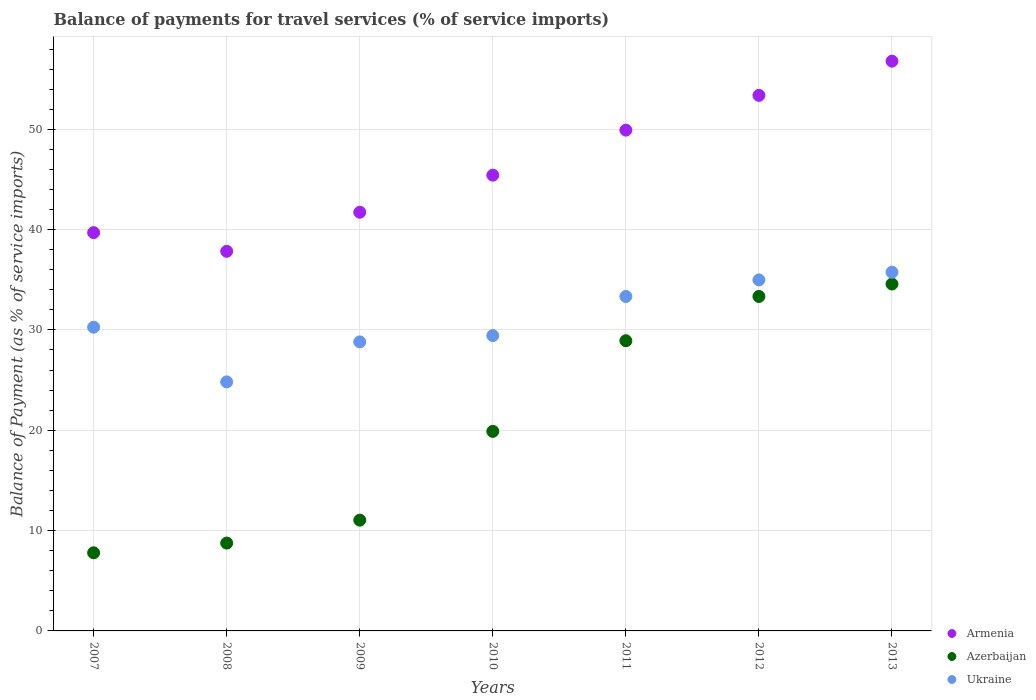How many different coloured dotlines are there?
Keep it short and to the point. 3. What is the balance of payments for travel services in Ukraine in 2011?
Offer a terse response. 33.33. Across all years, what is the maximum balance of payments for travel services in Armenia?
Your answer should be compact. 56.79. Across all years, what is the minimum balance of payments for travel services in Armenia?
Your answer should be compact. 37.84. In which year was the balance of payments for travel services in Ukraine maximum?
Offer a terse response. 2013. In which year was the balance of payments for travel services in Ukraine minimum?
Provide a succinct answer. 2008. What is the total balance of payments for travel services in Ukraine in the graph?
Provide a short and direct response. 217.41. What is the difference between the balance of payments for travel services in Armenia in 2007 and that in 2011?
Your answer should be very brief. -10.22. What is the difference between the balance of payments for travel services in Azerbaijan in 2011 and the balance of payments for travel services in Armenia in 2010?
Provide a short and direct response. -16.5. What is the average balance of payments for travel services in Armenia per year?
Ensure brevity in your answer.  46.4. In the year 2013, what is the difference between the balance of payments for travel services in Armenia and balance of payments for travel services in Ukraine?
Keep it short and to the point. 21.04. In how many years, is the balance of payments for travel services in Ukraine greater than 42 %?
Make the answer very short. 0. What is the ratio of the balance of payments for travel services in Ukraine in 2007 to that in 2013?
Offer a terse response. 0.85. What is the difference between the highest and the second highest balance of payments for travel services in Azerbaijan?
Your answer should be very brief. 1.24. What is the difference between the highest and the lowest balance of payments for travel services in Azerbaijan?
Give a very brief answer. 26.79. In how many years, is the balance of payments for travel services in Ukraine greater than the average balance of payments for travel services in Ukraine taken over all years?
Give a very brief answer. 3. Is the balance of payments for travel services in Armenia strictly less than the balance of payments for travel services in Ukraine over the years?
Provide a succinct answer. No. How many dotlines are there?
Your response must be concise. 3. How many years are there in the graph?
Your answer should be compact. 7. What is the difference between two consecutive major ticks on the Y-axis?
Make the answer very short. 10. Are the values on the major ticks of Y-axis written in scientific E-notation?
Keep it short and to the point. No. Where does the legend appear in the graph?
Your answer should be compact. Bottom right. How are the legend labels stacked?
Provide a succinct answer. Vertical. What is the title of the graph?
Your answer should be very brief. Balance of payments for travel services (% of service imports). What is the label or title of the Y-axis?
Your response must be concise. Balance of Payment (as % of service imports). What is the Balance of Payment (as % of service imports) of Armenia in 2007?
Your answer should be compact. 39.7. What is the Balance of Payment (as % of service imports) in Azerbaijan in 2007?
Your answer should be compact. 7.79. What is the Balance of Payment (as % of service imports) in Ukraine in 2007?
Provide a succinct answer. 30.27. What is the Balance of Payment (as % of service imports) in Armenia in 2008?
Your answer should be very brief. 37.84. What is the Balance of Payment (as % of service imports) of Azerbaijan in 2008?
Your answer should be very brief. 8.75. What is the Balance of Payment (as % of service imports) of Ukraine in 2008?
Ensure brevity in your answer.  24.82. What is the Balance of Payment (as % of service imports) of Armenia in 2009?
Your answer should be very brief. 41.73. What is the Balance of Payment (as % of service imports) of Azerbaijan in 2009?
Your answer should be very brief. 11.04. What is the Balance of Payment (as % of service imports) in Ukraine in 2009?
Keep it short and to the point. 28.81. What is the Balance of Payment (as % of service imports) of Armenia in 2010?
Give a very brief answer. 45.43. What is the Balance of Payment (as % of service imports) of Azerbaijan in 2010?
Provide a succinct answer. 19.89. What is the Balance of Payment (as % of service imports) in Ukraine in 2010?
Offer a terse response. 29.44. What is the Balance of Payment (as % of service imports) in Armenia in 2011?
Offer a terse response. 49.91. What is the Balance of Payment (as % of service imports) of Azerbaijan in 2011?
Keep it short and to the point. 28.92. What is the Balance of Payment (as % of service imports) in Ukraine in 2011?
Offer a very short reply. 33.33. What is the Balance of Payment (as % of service imports) in Armenia in 2012?
Offer a very short reply. 53.38. What is the Balance of Payment (as % of service imports) in Azerbaijan in 2012?
Provide a succinct answer. 33.34. What is the Balance of Payment (as % of service imports) of Ukraine in 2012?
Ensure brevity in your answer.  34.99. What is the Balance of Payment (as % of service imports) in Armenia in 2013?
Keep it short and to the point. 56.79. What is the Balance of Payment (as % of service imports) in Azerbaijan in 2013?
Give a very brief answer. 34.57. What is the Balance of Payment (as % of service imports) in Ukraine in 2013?
Offer a terse response. 35.75. Across all years, what is the maximum Balance of Payment (as % of service imports) in Armenia?
Your response must be concise. 56.79. Across all years, what is the maximum Balance of Payment (as % of service imports) in Azerbaijan?
Keep it short and to the point. 34.57. Across all years, what is the maximum Balance of Payment (as % of service imports) in Ukraine?
Offer a terse response. 35.75. Across all years, what is the minimum Balance of Payment (as % of service imports) of Armenia?
Your answer should be very brief. 37.84. Across all years, what is the minimum Balance of Payment (as % of service imports) of Azerbaijan?
Offer a very short reply. 7.79. Across all years, what is the minimum Balance of Payment (as % of service imports) of Ukraine?
Ensure brevity in your answer.  24.82. What is the total Balance of Payment (as % of service imports) in Armenia in the graph?
Make the answer very short. 324.77. What is the total Balance of Payment (as % of service imports) in Azerbaijan in the graph?
Provide a short and direct response. 144.31. What is the total Balance of Payment (as % of service imports) of Ukraine in the graph?
Keep it short and to the point. 217.41. What is the difference between the Balance of Payment (as % of service imports) of Armenia in 2007 and that in 2008?
Provide a short and direct response. 1.86. What is the difference between the Balance of Payment (as % of service imports) in Azerbaijan in 2007 and that in 2008?
Give a very brief answer. -0.97. What is the difference between the Balance of Payment (as % of service imports) of Ukraine in 2007 and that in 2008?
Provide a short and direct response. 5.45. What is the difference between the Balance of Payment (as % of service imports) in Armenia in 2007 and that in 2009?
Your response must be concise. -2.03. What is the difference between the Balance of Payment (as % of service imports) in Azerbaijan in 2007 and that in 2009?
Provide a short and direct response. -3.26. What is the difference between the Balance of Payment (as % of service imports) of Ukraine in 2007 and that in 2009?
Offer a terse response. 1.47. What is the difference between the Balance of Payment (as % of service imports) in Armenia in 2007 and that in 2010?
Make the answer very short. -5.73. What is the difference between the Balance of Payment (as % of service imports) in Azerbaijan in 2007 and that in 2010?
Keep it short and to the point. -12.1. What is the difference between the Balance of Payment (as % of service imports) in Ukraine in 2007 and that in 2010?
Provide a succinct answer. 0.83. What is the difference between the Balance of Payment (as % of service imports) in Armenia in 2007 and that in 2011?
Your response must be concise. -10.22. What is the difference between the Balance of Payment (as % of service imports) in Azerbaijan in 2007 and that in 2011?
Make the answer very short. -21.14. What is the difference between the Balance of Payment (as % of service imports) in Ukraine in 2007 and that in 2011?
Give a very brief answer. -3.06. What is the difference between the Balance of Payment (as % of service imports) in Armenia in 2007 and that in 2012?
Give a very brief answer. -13.68. What is the difference between the Balance of Payment (as % of service imports) of Azerbaijan in 2007 and that in 2012?
Offer a terse response. -25.55. What is the difference between the Balance of Payment (as % of service imports) in Ukraine in 2007 and that in 2012?
Keep it short and to the point. -4.71. What is the difference between the Balance of Payment (as % of service imports) in Armenia in 2007 and that in 2013?
Provide a succinct answer. -17.09. What is the difference between the Balance of Payment (as % of service imports) in Azerbaijan in 2007 and that in 2013?
Provide a succinct answer. -26.79. What is the difference between the Balance of Payment (as % of service imports) in Ukraine in 2007 and that in 2013?
Give a very brief answer. -5.48. What is the difference between the Balance of Payment (as % of service imports) of Armenia in 2008 and that in 2009?
Your answer should be compact. -3.89. What is the difference between the Balance of Payment (as % of service imports) in Azerbaijan in 2008 and that in 2009?
Your answer should be very brief. -2.29. What is the difference between the Balance of Payment (as % of service imports) of Ukraine in 2008 and that in 2009?
Your answer should be very brief. -3.99. What is the difference between the Balance of Payment (as % of service imports) of Armenia in 2008 and that in 2010?
Your answer should be compact. -7.59. What is the difference between the Balance of Payment (as % of service imports) in Azerbaijan in 2008 and that in 2010?
Offer a very short reply. -11.13. What is the difference between the Balance of Payment (as % of service imports) of Ukraine in 2008 and that in 2010?
Offer a terse response. -4.62. What is the difference between the Balance of Payment (as % of service imports) of Armenia in 2008 and that in 2011?
Provide a succinct answer. -12.08. What is the difference between the Balance of Payment (as % of service imports) in Azerbaijan in 2008 and that in 2011?
Your answer should be compact. -20.17. What is the difference between the Balance of Payment (as % of service imports) of Ukraine in 2008 and that in 2011?
Your answer should be compact. -8.51. What is the difference between the Balance of Payment (as % of service imports) in Armenia in 2008 and that in 2012?
Your answer should be very brief. -15.54. What is the difference between the Balance of Payment (as % of service imports) in Azerbaijan in 2008 and that in 2012?
Offer a terse response. -24.58. What is the difference between the Balance of Payment (as % of service imports) in Ukraine in 2008 and that in 2012?
Ensure brevity in your answer.  -10.16. What is the difference between the Balance of Payment (as % of service imports) in Armenia in 2008 and that in 2013?
Make the answer very short. -18.95. What is the difference between the Balance of Payment (as % of service imports) in Azerbaijan in 2008 and that in 2013?
Keep it short and to the point. -25.82. What is the difference between the Balance of Payment (as % of service imports) in Ukraine in 2008 and that in 2013?
Offer a very short reply. -10.93. What is the difference between the Balance of Payment (as % of service imports) of Armenia in 2009 and that in 2010?
Keep it short and to the point. -3.7. What is the difference between the Balance of Payment (as % of service imports) of Azerbaijan in 2009 and that in 2010?
Offer a terse response. -8.85. What is the difference between the Balance of Payment (as % of service imports) of Ukraine in 2009 and that in 2010?
Your answer should be compact. -0.63. What is the difference between the Balance of Payment (as % of service imports) in Armenia in 2009 and that in 2011?
Your response must be concise. -8.19. What is the difference between the Balance of Payment (as % of service imports) in Azerbaijan in 2009 and that in 2011?
Your response must be concise. -17.88. What is the difference between the Balance of Payment (as % of service imports) in Ukraine in 2009 and that in 2011?
Provide a succinct answer. -4.53. What is the difference between the Balance of Payment (as % of service imports) in Armenia in 2009 and that in 2012?
Provide a short and direct response. -11.65. What is the difference between the Balance of Payment (as % of service imports) of Azerbaijan in 2009 and that in 2012?
Your answer should be compact. -22.3. What is the difference between the Balance of Payment (as % of service imports) in Ukraine in 2009 and that in 2012?
Make the answer very short. -6.18. What is the difference between the Balance of Payment (as % of service imports) in Armenia in 2009 and that in 2013?
Provide a short and direct response. -15.06. What is the difference between the Balance of Payment (as % of service imports) of Azerbaijan in 2009 and that in 2013?
Your answer should be compact. -23.53. What is the difference between the Balance of Payment (as % of service imports) of Ukraine in 2009 and that in 2013?
Make the answer very short. -6.95. What is the difference between the Balance of Payment (as % of service imports) in Armenia in 2010 and that in 2011?
Offer a very short reply. -4.49. What is the difference between the Balance of Payment (as % of service imports) in Azerbaijan in 2010 and that in 2011?
Offer a very short reply. -9.04. What is the difference between the Balance of Payment (as % of service imports) of Ukraine in 2010 and that in 2011?
Provide a short and direct response. -3.9. What is the difference between the Balance of Payment (as % of service imports) in Armenia in 2010 and that in 2012?
Ensure brevity in your answer.  -7.95. What is the difference between the Balance of Payment (as % of service imports) of Azerbaijan in 2010 and that in 2012?
Offer a terse response. -13.45. What is the difference between the Balance of Payment (as % of service imports) in Ukraine in 2010 and that in 2012?
Provide a short and direct response. -5.55. What is the difference between the Balance of Payment (as % of service imports) of Armenia in 2010 and that in 2013?
Keep it short and to the point. -11.36. What is the difference between the Balance of Payment (as % of service imports) in Azerbaijan in 2010 and that in 2013?
Ensure brevity in your answer.  -14.69. What is the difference between the Balance of Payment (as % of service imports) in Ukraine in 2010 and that in 2013?
Your answer should be compact. -6.32. What is the difference between the Balance of Payment (as % of service imports) in Armenia in 2011 and that in 2012?
Give a very brief answer. -3.46. What is the difference between the Balance of Payment (as % of service imports) in Azerbaijan in 2011 and that in 2012?
Ensure brevity in your answer.  -4.41. What is the difference between the Balance of Payment (as % of service imports) of Ukraine in 2011 and that in 2012?
Ensure brevity in your answer.  -1.65. What is the difference between the Balance of Payment (as % of service imports) in Armenia in 2011 and that in 2013?
Your response must be concise. -6.87. What is the difference between the Balance of Payment (as % of service imports) in Azerbaijan in 2011 and that in 2013?
Offer a terse response. -5.65. What is the difference between the Balance of Payment (as % of service imports) of Ukraine in 2011 and that in 2013?
Offer a very short reply. -2.42. What is the difference between the Balance of Payment (as % of service imports) of Armenia in 2012 and that in 2013?
Ensure brevity in your answer.  -3.41. What is the difference between the Balance of Payment (as % of service imports) in Azerbaijan in 2012 and that in 2013?
Provide a succinct answer. -1.24. What is the difference between the Balance of Payment (as % of service imports) of Ukraine in 2012 and that in 2013?
Ensure brevity in your answer.  -0.77. What is the difference between the Balance of Payment (as % of service imports) of Armenia in 2007 and the Balance of Payment (as % of service imports) of Azerbaijan in 2008?
Your answer should be very brief. 30.94. What is the difference between the Balance of Payment (as % of service imports) in Armenia in 2007 and the Balance of Payment (as % of service imports) in Ukraine in 2008?
Keep it short and to the point. 14.88. What is the difference between the Balance of Payment (as % of service imports) of Azerbaijan in 2007 and the Balance of Payment (as % of service imports) of Ukraine in 2008?
Give a very brief answer. -17.04. What is the difference between the Balance of Payment (as % of service imports) in Armenia in 2007 and the Balance of Payment (as % of service imports) in Azerbaijan in 2009?
Offer a terse response. 28.66. What is the difference between the Balance of Payment (as % of service imports) in Armenia in 2007 and the Balance of Payment (as % of service imports) in Ukraine in 2009?
Your response must be concise. 10.89. What is the difference between the Balance of Payment (as % of service imports) of Azerbaijan in 2007 and the Balance of Payment (as % of service imports) of Ukraine in 2009?
Provide a succinct answer. -21.02. What is the difference between the Balance of Payment (as % of service imports) in Armenia in 2007 and the Balance of Payment (as % of service imports) in Azerbaijan in 2010?
Your answer should be compact. 19.81. What is the difference between the Balance of Payment (as % of service imports) in Armenia in 2007 and the Balance of Payment (as % of service imports) in Ukraine in 2010?
Provide a succinct answer. 10.26. What is the difference between the Balance of Payment (as % of service imports) of Azerbaijan in 2007 and the Balance of Payment (as % of service imports) of Ukraine in 2010?
Provide a succinct answer. -21.65. What is the difference between the Balance of Payment (as % of service imports) in Armenia in 2007 and the Balance of Payment (as % of service imports) in Azerbaijan in 2011?
Make the answer very short. 10.77. What is the difference between the Balance of Payment (as % of service imports) of Armenia in 2007 and the Balance of Payment (as % of service imports) of Ukraine in 2011?
Your response must be concise. 6.36. What is the difference between the Balance of Payment (as % of service imports) of Azerbaijan in 2007 and the Balance of Payment (as % of service imports) of Ukraine in 2011?
Your answer should be very brief. -25.55. What is the difference between the Balance of Payment (as % of service imports) in Armenia in 2007 and the Balance of Payment (as % of service imports) in Azerbaijan in 2012?
Make the answer very short. 6.36. What is the difference between the Balance of Payment (as % of service imports) of Armenia in 2007 and the Balance of Payment (as % of service imports) of Ukraine in 2012?
Your answer should be very brief. 4.71. What is the difference between the Balance of Payment (as % of service imports) in Azerbaijan in 2007 and the Balance of Payment (as % of service imports) in Ukraine in 2012?
Give a very brief answer. -27.2. What is the difference between the Balance of Payment (as % of service imports) in Armenia in 2007 and the Balance of Payment (as % of service imports) in Azerbaijan in 2013?
Offer a terse response. 5.12. What is the difference between the Balance of Payment (as % of service imports) in Armenia in 2007 and the Balance of Payment (as % of service imports) in Ukraine in 2013?
Your response must be concise. 3.95. What is the difference between the Balance of Payment (as % of service imports) of Azerbaijan in 2007 and the Balance of Payment (as % of service imports) of Ukraine in 2013?
Your answer should be very brief. -27.97. What is the difference between the Balance of Payment (as % of service imports) of Armenia in 2008 and the Balance of Payment (as % of service imports) of Azerbaijan in 2009?
Give a very brief answer. 26.8. What is the difference between the Balance of Payment (as % of service imports) in Armenia in 2008 and the Balance of Payment (as % of service imports) in Ukraine in 2009?
Keep it short and to the point. 9.03. What is the difference between the Balance of Payment (as % of service imports) of Azerbaijan in 2008 and the Balance of Payment (as % of service imports) of Ukraine in 2009?
Provide a succinct answer. -20.05. What is the difference between the Balance of Payment (as % of service imports) of Armenia in 2008 and the Balance of Payment (as % of service imports) of Azerbaijan in 2010?
Provide a succinct answer. 17.95. What is the difference between the Balance of Payment (as % of service imports) of Armenia in 2008 and the Balance of Payment (as % of service imports) of Ukraine in 2010?
Your answer should be very brief. 8.4. What is the difference between the Balance of Payment (as % of service imports) of Azerbaijan in 2008 and the Balance of Payment (as % of service imports) of Ukraine in 2010?
Make the answer very short. -20.68. What is the difference between the Balance of Payment (as % of service imports) in Armenia in 2008 and the Balance of Payment (as % of service imports) in Azerbaijan in 2011?
Offer a terse response. 8.91. What is the difference between the Balance of Payment (as % of service imports) of Armenia in 2008 and the Balance of Payment (as % of service imports) of Ukraine in 2011?
Your response must be concise. 4.5. What is the difference between the Balance of Payment (as % of service imports) of Azerbaijan in 2008 and the Balance of Payment (as % of service imports) of Ukraine in 2011?
Provide a short and direct response. -24.58. What is the difference between the Balance of Payment (as % of service imports) of Armenia in 2008 and the Balance of Payment (as % of service imports) of Azerbaijan in 2012?
Your response must be concise. 4.5. What is the difference between the Balance of Payment (as % of service imports) in Armenia in 2008 and the Balance of Payment (as % of service imports) in Ukraine in 2012?
Ensure brevity in your answer.  2.85. What is the difference between the Balance of Payment (as % of service imports) of Azerbaijan in 2008 and the Balance of Payment (as % of service imports) of Ukraine in 2012?
Keep it short and to the point. -26.23. What is the difference between the Balance of Payment (as % of service imports) in Armenia in 2008 and the Balance of Payment (as % of service imports) in Azerbaijan in 2013?
Your answer should be compact. 3.26. What is the difference between the Balance of Payment (as % of service imports) of Armenia in 2008 and the Balance of Payment (as % of service imports) of Ukraine in 2013?
Make the answer very short. 2.08. What is the difference between the Balance of Payment (as % of service imports) in Azerbaijan in 2008 and the Balance of Payment (as % of service imports) in Ukraine in 2013?
Provide a short and direct response. -27. What is the difference between the Balance of Payment (as % of service imports) in Armenia in 2009 and the Balance of Payment (as % of service imports) in Azerbaijan in 2010?
Provide a succinct answer. 21.84. What is the difference between the Balance of Payment (as % of service imports) of Armenia in 2009 and the Balance of Payment (as % of service imports) of Ukraine in 2010?
Make the answer very short. 12.29. What is the difference between the Balance of Payment (as % of service imports) in Azerbaijan in 2009 and the Balance of Payment (as % of service imports) in Ukraine in 2010?
Offer a very short reply. -18.4. What is the difference between the Balance of Payment (as % of service imports) in Armenia in 2009 and the Balance of Payment (as % of service imports) in Azerbaijan in 2011?
Your answer should be compact. 12.81. What is the difference between the Balance of Payment (as % of service imports) in Armenia in 2009 and the Balance of Payment (as % of service imports) in Ukraine in 2011?
Keep it short and to the point. 8.4. What is the difference between the Balance of Payment (as % of service imports) in Azerbaijan in 2009 and the Balance of Payment (as % of service imports) in Ukraine in 2011?
Offer a terse response. -22.29. What is the difference between the Balance of Payment (as % of service imports) in Armenia in 2009 and the Balance of Payment (as % of service imports) in Azerbaijan in 2012?
Give a very brief answer. 8.39. What is the difference between the Balance of Payment (as % of service imports) in Armenia in 2009 and the Balance of Payment (as % of service imports) in Ukraine in 2012?
Give a very brief answer. 6.74. What is the difference between the Balance of Payment (as % of service imports) in Azerbaijan in 2009 and the Balance of Payment (as % of service imports) in Ukraine in 2012?
Offer a terse response. -23.94. What is the difference between the Balance of Payment (as % of service imports) of Armenia in 2009 and the Balance of Payment (as % of service imports) of Azerbaijan in 2013?
Offer a very short reply. 7.15. What is the difference between the Balance of Payment (as % of service imports) in Armenia in 2009 and the Balance of Payment (as % of service imports) in Ukraine in 2013?
Offer a terse response. 5.98. What is the difference between the Balance of Payment (as % of service imports) of Azerbaijan in 2009 and the Balance of Payment (as % of service imports) of Ukraine in 2013?
Make the answer very short. -24.71. What is the difference between the Balance of Payment (as % of service imports) in Armenia in 2010 and the Balance of Payment (as % of service imports) in Azerbaijan in 2011?
Your answer should be compact. 16.5. What is the difference between the Balance of Payment (as % of service imports) of Armenia in 2010 and the Balance of Payment (as % of service imports) of Ukraine in 2011?
Your answer should be very brief. 12.09. What is the difference between the Balance of Payment (as % of service imports) in Azerbaijan in 2010 and the Balance of Payment (as % of service imports) in Ukraine in 2011?
Offer a very short reply. -13.44. What is the difference between the Balance of Payment (as % of service imports) in Armenia in 2010 and the Balance of Payment (as % of service imports) in Azerbaijan in 2012?
Make the answer very short. 12.09. What is the difference between the Balance of Payment (as % of service imports) in Armenia in 2010 and the Balance of Payment (as % of service imports) in Ukraine in 2012?
Your answer should be very brief. 10.44. What is the difference between the Balance of Payment (as % of service imports) in Azerbaijan in 2010 and the Balance of Payment (as % of service imports) in Ukraine in 2012?
Your answer should be very brief. -15.1. What is the difference between the Balance of Payment (as % of service imports) of Armenia in 2010 and the Balance of Payment (as % of service imports) of Azerbaijan in 2013?
Ensure brevity in your answer.  10.85. What is the difference between the Balance of Payment (as % of service imports) in Armenia in 2010 and the Balance of Payment (as % of service imports) in Ukraine in 2013?
Provide a succinct answer. 9.67. What is the difference between the Balance of Payment (as % of service imports) of Azerbaijan in 2010 and the Balance of Payment (as % of service imports) of Ukraine in 2013?
Provide a short and direct response. -15.86. What is the difference between the Balance of Payment (as % of service imports) in Armenia in 2011 and the Balance of Payment (as % of service imports) in Azerbaijan in 2012?
Ensure brevity in your answer.  16.58. What is the difference between the Balance of Payment (as % of service imports) of Armenia in 2011 and the Balance of Payment (as % of service imports) of Ukraine in 2012?
Provide a succinct answer. 14.93. What is the difference between the Balance of Payment (as % of service imports) in Azerbaijan in 2011 and the Balance of Payment (as % of service imports) in Ukraine in 2012?
Provide a short and direct response. -6.06. What is the difference between the Balance of Payment (as % of service imports) in Armenia in 2011 and the Balance of Payment (as % of service imports) in Azerbaijan in 2013?
Offer a terse response. 15.34. What is the difference between the Balance of Payment (as % of service imports) of Armenia in 2011 and the Balance of Payment (as % of service imports) of Ukraine in 2013?
Your answer should be compact. 14.16. What is the difference between the Balance of Payment (as % of service imports) in Azerbaijan in 2011 and the Balance of Payment (as % of service imports) in Ukraine in 2013?
Ensure brevity in your answer.  -6.83. What is the difference between the Balance of Payment (as % of service imports) in Armenia in 2012 and the Balance of Payment (as % of service imports) in Azerbaijan in 2013?
Offer a very short reply. 18.8. What is the difference between the Balance of Payment (as % of service imports) in Armenia in 2012 and the Balance of Payment (as % of service imports) in Ukraine in 2013?
Give a very brief answer. 17.63. What is the difference between the Balance of Payment (as % of service imports) in Azerbaijan in 2012 and the Balance of Payment (as % of service imports) in Ukraine in 2013?
Ensure brevity in your answer.  -2.42. What is the average Balance of Payment (as % of service imports) of Armenia per year?
Your answer should be compact. 46.4. What is the average Balance of Payment (as % of service imports) in Azerbaijan per year?
Provide a succinct answer. 20.62. What is the average Balance of Payment (as % of service imports) in Ukraine per year?
Offer a terse response. 31.06. In the year 2007, what is the difference between the Balance of Payment (as % of service imports) in Armenia and Balance of Payment (as % of service imports) in Azerbaijan?
Keep it short and to the point. 31.91. In the year 2007, what is the difference between the Balance of Payment (as % of service imports) of Armenia and Balance of Payment (as % of service imports) of Ukraine?
Your response must be concise. 9.43. In the year 2007, what is the difference between the Balance of Payment (as % of service imports) of Azerbaijan and Balance of Payment (as % of service imports) of Ukraine?
Your response must be concise. -22.49. In the year 2008, what is the difference between the Balance of Payment (as % of service imports) of Armenia and Balance of Payment (as % of service imports) of Azerbaijan?
Ensure brevity in your answer.  29.08. In the year 2008, what is the difference between the Balance of Payment (as % of service imports) in Armenia and Balance of Payment (as % of service imports) in Ukraine?
Your answer should be compact. 13.02. In the year 2008, what is the difference between the Balance of Payment (as % of service imports) in Azerbaijan and Balance of Payment (as % of service imports) in Ukraine?
Ensure brevity in your answer.  -16.07. In the year 2009, what is the difference between the Balance of Payment (as % of service imports) of Armenia and Balance of Payment (as % of service imports) of Azerbaijan?
Your answer should be very brief. 30.69. In the year 2009, what is the difference between the Balance of Payment (as % of service imports) of Armenia and Balance of Payment (as % of service imports) of Ukraine?
Your answer should be very brief. 12.92. In the year 2009, what is the difference between the Balance of Payment (as % of service imports) of Azerbaijan and Balance of Payment (as % of service imports) of Ukraine?
Your response must be concise. -17.77. In the year 2010, what is the difference between the Balance of Payment (as % of service imports) of Armenia and Balance of Payment (as % of service imports) of Azerbaijan?
Provide a succinct answer. 25.54. In the year 2010, what is the difference between the Balance of Payment (as % of service imports) of Armenia and Balance of Payment (as % of service imports) of Ukraine?
Your response must be concise. 15.99. In the year 2010, what is the difference between the Balance of Payment (as % of service imports) in Azerbaijan and Balance of Payment (as % of service imports) in Ukraine?
Your answer should be very brief. -9.55. In the year 2011, what is the difference between the Balance of Payment (as % of service imports) in Armenia and Balance of Payment (as % of service imports) in Azerbaijan?
Offer a very short reply. 20.99. In the year 2011, what is the difference between the Balance of Payment (as % of service imports) of Armenia and Balance of Payment (as % of service imports) of Ukraine?
Give a very brief answer. 16.58. In the year 2011, what is the difference between the Balance of Payment (as % of service imports) of Azerbaijan and Balance of Payment (as % of service imports) of Ukraine?
Offer a very short reply. -4.41. In the year 2012, what is the difference between the Balance of Payment (as % of service imports) in Armenia and Balance of Payment (as % of service imports) in Azerbaijan?
Make the answer very short. 20.04. In the year 2012, what is the difference between the Balance of Payment (as % of service imports) of Armenia and Balance of Payment (as % of service imports) of Ukraine?
Your answer should be compact. 18.39. In the year 2012, what is the difference between the Balance of Payment (as % of service imports) of Azerbaijan and Balance of Payment (as % of service imports) of Ukraine?
Your response must be concise. -1.65. In the year 2013, what is the difference between the Balance of Payment (as % of service imports) of Armenia and Balance of Payment (as % of service imports) of Azerbaijan?
Give a very brief answer. 22.21. In the year 2013, what is the difference between the Balance of Payment (as % of service imports) of Armenia and Balance of Payment (as % of service imports) of Ukraine?
Provide a succinct answer. 21.04. In the year 2013, what is the difference between the Balance of Payment (as % of service imports) in Azerbaijan and Balance of Payment (as % of service imports) in Ukraine?
Provide a succinct answer. -1.18. What is the ratio of the Balance of Payment (as % of service imports) of Armenia in 2007 to that in 2008?
Offer a terse response. 1.05. What is the ratio of the Balance of Payment (as % of service imports) of Azerbaijan in 2007 to that in 2008?
Your response must be concise. 0.89. What is the ratio of the Balance of Payment (as % of service imports) of Ukraine in 2007 to that in 2008?
Offer a very short reply. 1.22. What is the ratio of the Balance of Payment (as % of service imports) of Armenia in 2007 to that in 2009?
Make the answer very short. 0.95. What is the ratio of the Balance of Payment (as % of service imports) in Azerbaijan in 2007 to that in 2009?
Keep it short and to the point. 0.71. What is the ratio of the Balance of Payment (as % of service imports) in Ukraine in 2007 to that in 2009?
Offer a terse response. 1.05. What is the ratio of the Balance of Payment (as % of service imports) of Armenia in 2007 to that in 2010?
Your response must be concise. 0.87. What is the ratio of the Balance of Payment (as % of service imports) of Azerbaijan in 2007 to that in 2010?
Ensure brevity in your answer.  0.39. What is the ratio of the Balance of Payment (as % of service imports) in Ukraine in 2007 to that in 2010?
Your answer should be very brief. 1.03. What is the ratio of the Balance of Payment (as % of service imports) in Armenia in 2007 to that in 2011?
Offer a very short reply. 0.8. What is the ratio of the Balance of Payment (as % of service imports) of Azerbaijan in 2007 to that in 2011?
Your answer should be compact. 0.27. What is the ratio of the Balance of Payment (as % of service imports) in Ukraine in 2007 to that in 2011?
Make the answer very short. 0.91. What is the ratio of the Balance of Payment (as % of service imports) of Armenia in 2007 to that in 2012?
Make the answer very short. 0.74. What is the ratio of the Balance of Payment (as % of service imports) of Azerbaijan in 2007 to that in 2012?
Your answer should be very brief. 0.23. What is the ratio of the Balance of Payment (as % of service imports) in Ukraine in 2007 to that in 2012?
Make the answer very short. 0.87. What is the ratio of the Balance of Payment (as % of service imports) in Armenia in 2007 to that in 2013?
Offer a very short reply. 0.7. What is the ratio of the Balance of Payment (as % of service imports) of Azerbaijan in 2007 to that in 2013?
Your answer should be very brief. 0.23. What is the ratio of the Balance of Payment (as % of service imports) of Ukraine in 2007 to that in 2013?
Ensure brevity in your answer.  0.85. What is the ratio of the Balance of Payment (as % of service imports) in Armenia in 2008 to that in 2009?
Provide a succinct answer. 0.91. What is the ratio of the Balance of Payment (as % of service imports) in Azerbaijan in 2008 to that in 2009?
Provide a succinct answer. 0.79. What is the ratio of the Balance of Payment (as % of service imports) in Ukraine in 2008 to that in 2009?
Your answer should be very brief. 0.86. What is the ratio of the Balance of Payment (as % of service imports) in Armenia in 2008 to that in 2010?
Provide a short and direct response. 0.83. What is the ratio of the Balance of Payment (as % of service imports) of Azerbaijan in 2008 to that in 2010?
Your answer should be compact. 0.44. What is the ratio of the Balance of Payment (as % of service imports) of Ukraine in 2008 to that in 2010?
Offer a very short reply. 0.84. What is the ratio of the Balance of Payment (as % of service imports) of Armenia in 2008 to that in 2011?
Provide a short and direct response. 0.76. What is the ratio of the Balance of Payment (as % of service imports) of Azerbaijan in 2008 to that in 2011?
Provide a short and direct response. 0.3. What is the ratio of the Balance of Payment (as % of service imports) in Ukraine in 2008 to that in 2011?
Provide a short and direct response. 0.74. What is the ratio of the Balance of Payment (as % of service imports) in Armenia in 2008 to that in 2012?
Give a very brief answer. 0.71. What is the ratio of the Balance of Payment (as % of service imports) of Azerbaijan in 2008 to that in 2012?
Your response must be concise. 0.26. What is the ratio of the Balance of Payment (as % of service imports) of Ukraine in 2008 to that in 2012?
Ensure brevity in your answer.  0.71. What is the ratio of the Balance of Payment (as % of service imports) of Armenia in 2008 to that in 2013?
Your answer should be compact. 0.67. What is the ratio of the Balance of Payment (as % of service imports) of Azerbaijan in 2008 to that in 2013?
Ensure brevity in your answer.  0.25. What is the ratio of the Balance of Payment (as % of service imports) of Ukraine in 2008 to that in 2013?
Provide a succinct answer. 0.69. What is the ratio of the Balance of Payment (as % of service imports) in Armenia in 2009 to that in 2010?
Your answer should be compact. 0.92. What is the ratio of the Balance of Payment (as % of service imports) in Azerbaijan in 2009 to that in 2010?
Give a very brief answer. 0.56. What is the ratio of the Balance of Payment (as % of service imports) in Ukraine in 2009 to that in 2010?
Your answer should be very brief. 0.98. What is the ratio of the Balance of Payment (as % of service imports) of Armenia in 2009 to that in 2011?
Provide a short and direct response. 0.84. What is the ratio of the Balance of Payment (as % of service imports) of Azerbaijan in 2009 to that in 2011?
Keep it short and to the point. 0.38. What is the ratio of the Balance of Payment (as % of service imports) in Ukraine in 2009 to that in 2011?
Your response must be concise. 0.86. What is the ratio of the Balance of Payment (as % of service imports) in Armenia in 2009 to that in 2012?
Give a very brief answer. 0.78. What is the ratio of the Balance of Payment (as % of service imports) of Azerbaijan in 2009 to that in 2012?
Keep it short and to the point. 0.33. What is the ratio of the Balance of Payment (as % of service imports) in Ukraine in 2009 to that in 2012?
Give a very brief answer. 0.82. What is the ratio of the Balance of Payment (as % of service imports) of Armenia in 2009 to that in 2013?
Make the answer very short. 0.73. What is the ratio of the Balance of Payment (as % of service imports) of Azerbaijan in 2009 to that in 2013?
Offer a terse response. 0.32. What is the ratio of the Balance of Payment (as % of service imports) in Ukraine in 2009 to that in 2013?
Your answer should be compact. 0.81. What is the ratio of the Balance of Payment (as % of service imports) of Armenia in 2010 to that in 2011?
Provide a short and direct response. 0.91. What is the ratio of the Balance of Payment (as % of service imports) of Azerbaijan in 2010 to that in 2011?
Provide a succinct answer. 0.69. What is the ratio of the Balance of Payment (as % of service imports) of Ukraine in 2010 to that in 2011?
Give a very brief answer. 0.88. What is the ratio of the Balance of Payment (as % of service imports) in Armenia in 2010 to that in 2012?
Offer a terse response. 0.85. What is the ratio of the Balance of Payment (as % of service imports) of Azerbaijan in 2010 to that in 2012?
Offer a terse response. 0.6. What is the ratio of the Balance of Payment (as % of service imports) of Ukraine in 2010 to that in 2012?
Keep it short and to the point. 0.84. What is the ratio of the Balance of Payment (as % of service imports) in Armenia in 2010 to that in 2013?
Give a very brief answer. 0.8. What is the ratio of the Balance of Payment (as % of service imports) of Azerbaijan in 2010 to that in 2013?
Your response must be concise. 0.58. What is the ratio of the Balance of Payment (as % of service imports) in Ukraine in 2010 to that in 2013?
Make the answer very short. 0.82. What is the ratio of the Balance of Payment (as % of service imports) in Armenia in 2011 to that in 2012?
Your answer should be very brief. 0.94. What is the ratio of the Balance of Payment (as % of service imports) in Azerbaijan in 2011 to that in 2012?
Provide a short and direct response. 0.87. What is the ratio of the Balance of Payment (as % of service imports) in Ukraine in 2011 to that in 2012?
Offer a very short reply. 0.95. What is the ratio of the Balance of Payment (as % of service imports) of Armenia in 2011 to that in 2013?
Offer a terse response. 0.88. What is the ratio of the Balance of Payment (as % of service imports) in Azerbaijan in 2011 to that in 2013?
Ensure brevity in your answer.  0.84. What is the ratio of the Balance of Payment (as % of service imports) in Ukraine in 2011 to that in 2013?
Your answer should be very brief. 0.93. What is the ratio of the Balance of Payment (as % of service imports) of Armenia in 2012 to that in 2013?
Make the answer very short. 0.94. What is the ratio of the Balance of Payment (as % of service imports) of Azerbaijan in 2012 to that in 2013?
Give a very brief answer. 0.96. What is the ratio of the Balance of Payment (as % of service imports) of Ukraine in 2012 to that in 2013?
Keep it short and to the point. 0.98. What is the difference between the highest and the second highest Balance of Payment (as % of service imports) in Armenia?
Offer a terse response. 3.41. What is the difference between the highest and the second highest Balance of Payment (as % of service imports) in Azerbaijan?
Your answer should be very brief. 1.24. What is the difference between the highest and the second highest Balance of Payment (as % of service imports) of Ukraine?
Give a very brief answer. 0.77. What is the difference between the highest and the lowest Balance of Payment (as % of service imports) of Armenia?
Your response must be concise. 18.95. What is the difference between the highest and the lowest Balance of Payment (as % of service imports) of Azerbaijan?
Your response must be concise. 26.79. What is the difference between the highest and the lowest Balance of Payment (as % of service imports) of Ukraine?
Offer a very short reply. 10.93. 